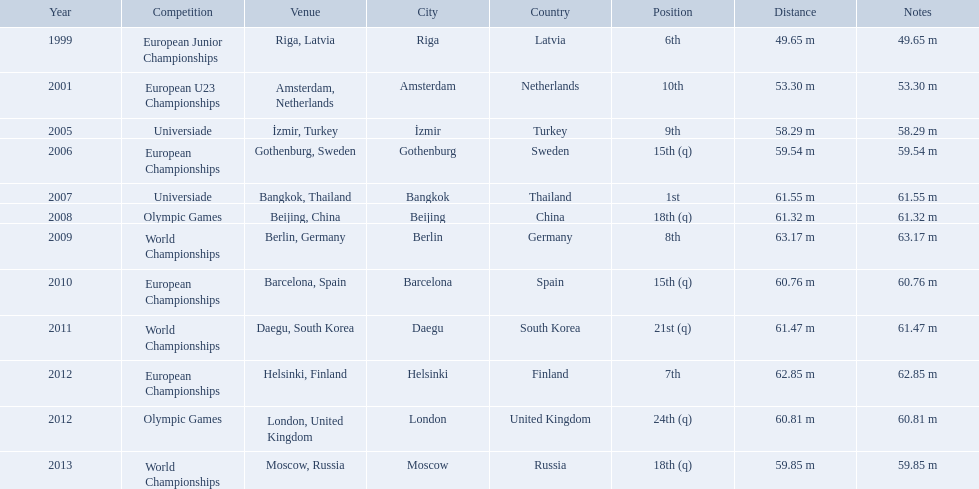What are all the competitions? European Junior Championships, European U23 Championships, Universiade, European Championships, Universiade, Olympic Games, World Championships, European Championships, World Championships, European Championships, Olympic Games, World Championships. What years did they place in the top 10? 1999, 2001, 2005, 2007, 2009, 2012. Besides when they placed first, which position was their highest? 6th. Could you parse the entire table? {'header': ['Year', 'Competition', 'Venue', 'City', 'Country', 'Position', 'Distance', 'Notes'], 'rows': [['1999', 'European Junior Championships', 'Riga, Latvia', 'Riga', 'Latvia', '6th', '49.65 m', '49.65 m'], ['2001', 'European U23 Championships', 'Amsterdam, Netherlands', 'Amsterdam', 'Netherlands', '10th', '53.30 m', '53.30 m'], ['2005', 'Universiade', 'İzmir, Turkey', 'İzmir', 'Turkey', '9th', '58.29 m', '58.29 m'], ['2006', 'European Championships', 'Gothenburg, Sweden', 'Gothenburg', 'Sweden', '15th (q)', '59.54 m', '59.54 m'], ['2007', 'Universiade', 'Bangkok, Thailand', 'Bangkok', 'Thailand', '1st', '61.55 m', '61.55 m'], ['2008', 'Olympic Games', 'Beijing, China', 'Beijing', 'China', '18th (q)', '61.32 m', '61.32 m'], ['2009', 'World Championships', 'Berlin, Germany', 'Berlin', 'Germany', '8th', '63.17 m', '63.17 m'], ['2010', 'European Championships', 'Barcelona, Spain', 'Barcelona', 'Spain', '15th (q)', '60.76 m', '60.76 m'], ['2011', 'World Championships', 'Daegu, South Korea', 'Daegu', 'South Korea', '21st (q)', '61.47 m', '61.47 m'], ['2012', 'European Championships', 'Helsinki, Finland', 'Helsinki', 'Finland', '7th', '62.85 m', '62.85 m'], ['2012', 'Olympic Games', 'London, United Kingdom', 'London', 'United Kingdom', '24th (q)', '60.81 m', '60.81 m'], ['2013', 'World Championships', 'Moscow, Russia', 'Moscow', 'Russia', '18th (q)', '59.85 m', '59.85 m']]} What european junior championships? 6th. I'm looking to parse the entire table for insights. Could you assist me with that? {'header': ['Year', 'Competition', 'Venue', 'City', 'Country', 'Position', 'Distance', 'Notes'], 'rows': [['1999', 'European Junior Championships', 'Riga, Latvia', 'Riga', 'Latvia', '6th', '49.65 m', '49.65 m'], ['2001', 'European U23 Championships', 'Amsterdam, Netherlands', 'Amsterdam', 'Netherlands', '10th', '53.30 m', '53.30 m'], ['2005', 'Universiade', 'İzmir, Turkey', 'İzmir', 'Turkey', '9th', '58.29 m', '58.29 m'], ['2006', 'European Championships', 'Gothenburg, Sweden', 'Gothenburg', 'Sweden', '15th (q)', '59.54 m', '59.54 m'], ['2007', 'Universiade', 'Bangkok, Thailand', 'Bangkok', 'Thailand', '1st', '61.55 m', '61.55 m'], ['2008', 'Olympic Games', 'Beijing, China', 'Beijing', 'China', '18th (q)', '61.32 m', '61.32 m'], ['2009', 'World Championships', 'Berlin, Germany', 'Berlin', 'Germany', '8th', '63.17 m', '63.17 m'], ['2010', 'European Championships', 'Barcelona, Spain', 'Barcelona', 'Spain', '15th (q)', '60.76 m', '60.76 m'], ['2011', 'World Championships', 'Daegu, South Korea', 'Daegu', 'South Korea', '21st (q)', '61.47 m', '61.47 m'], ['2012', 'European Championships', 'Helsinki, Finland', 'Helsinki', 'Finland', '7th', '62.85 m', '62.85 m'], ['2012', 'Olympic Games', 'London, United Kingdom', 'London', 'United Kingdom', '24th (q)', '60.81 m', '60.81 m'], ['2013', 'World Championships', 'Moscow, Russia', 'Moscow', 'Russia', '18th (q)', '59.85 m', '59.85 m']]} What waseuropean junior championships best result? 63.17 m. What were the distances of mayer's throws? 49.65 m, 53.30 m, 58.29 m, 59.54 m, 61.55 m, 61.32 m, 63.17 m, 60.76 m, 61.47 m, 62.85 m, 60.81 m, 59.85 m. Which of these went the farthest? 63.17 m. Which competitions has gerhard mayer competed in since 1999? European Junior Championships, European U23 Championships, Universiade, European Championships, Universiade, Olympic Games, World Championships, European Championships, World Championships, European Championships, Olympic Games, World Championships. Of these competition, in which ones did he throw at least 60 m? Universiade, Olympic Games, World Championships, European Championships, World Championships, European Championships, Olympic Games. Of these throws, which was his longest? 63.17 m. 